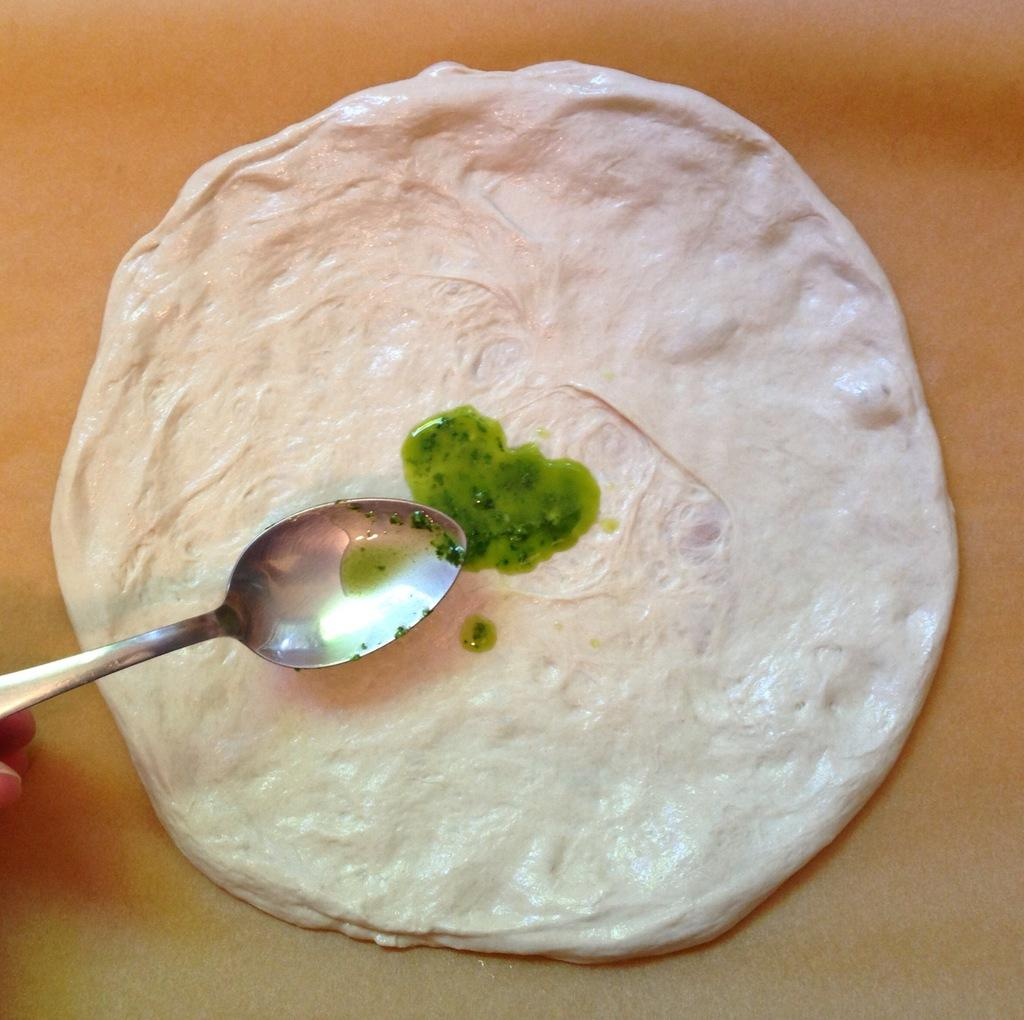What is the color of the surface on which the food is placed in the image? The surface is yellow. What is the color of the object placed on the food? The object is green. How was the green object placed on the food? It was placed by a spoon. What type of riddle is depicted on the food in the image? There is no riddle depicted on the food in the image. What is the purpose of the yoke in the image? There is no yoke present in the image. 